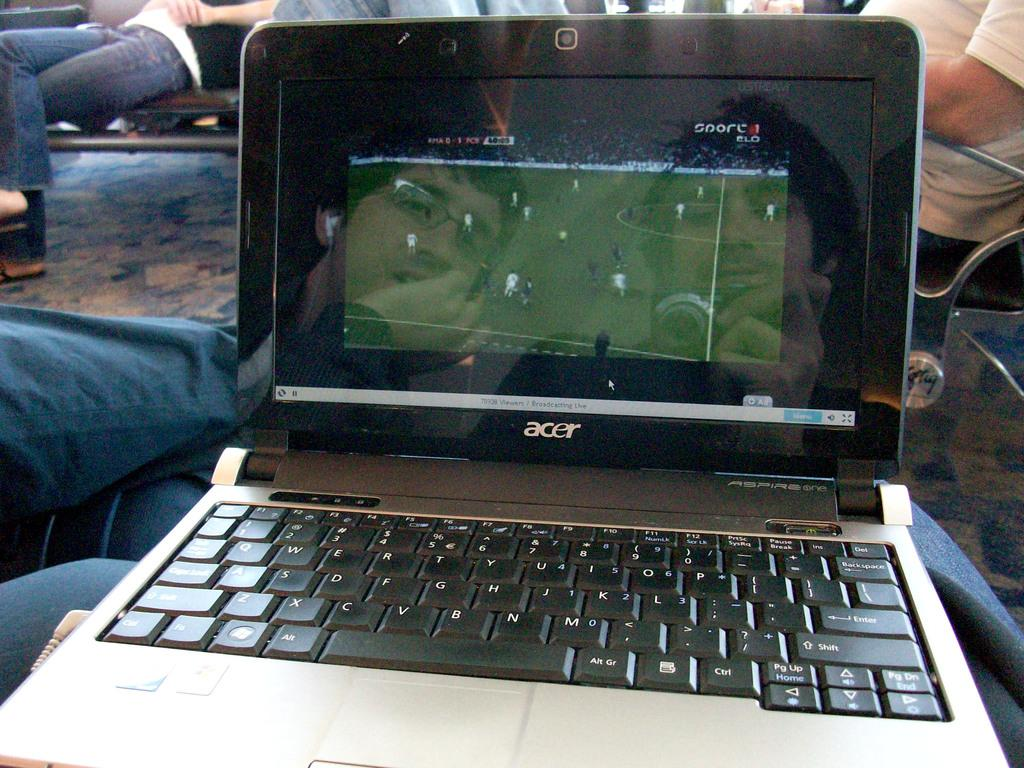Provide a one-sentence caption for the provided image. an ACER lap top computer open to a soccer game. 